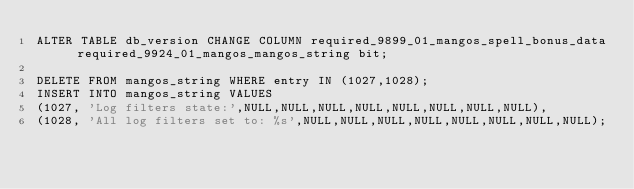<code> <loc_0><loc_0><loc_500><loc_500><_SQL_>ALTER TABLE db_version CHANGE COLUMN required_9899_01_mangos_spell_bonus_data required_9924_01_mangos_mangos_string bit;

DELETE FROM mangos_string WHERE entry IN (1027,1028);
INSERT INTO mangos_string VALUES
(1027, 'Log filters state:',NULL,NULL,NULL,NULL,NULL,NULL,NULL,NULL),
(1028, 'All log filters set to: %s',NULL,NULL,NULL,NULL,NULL,NULL,NULL,NULL);
</code> 